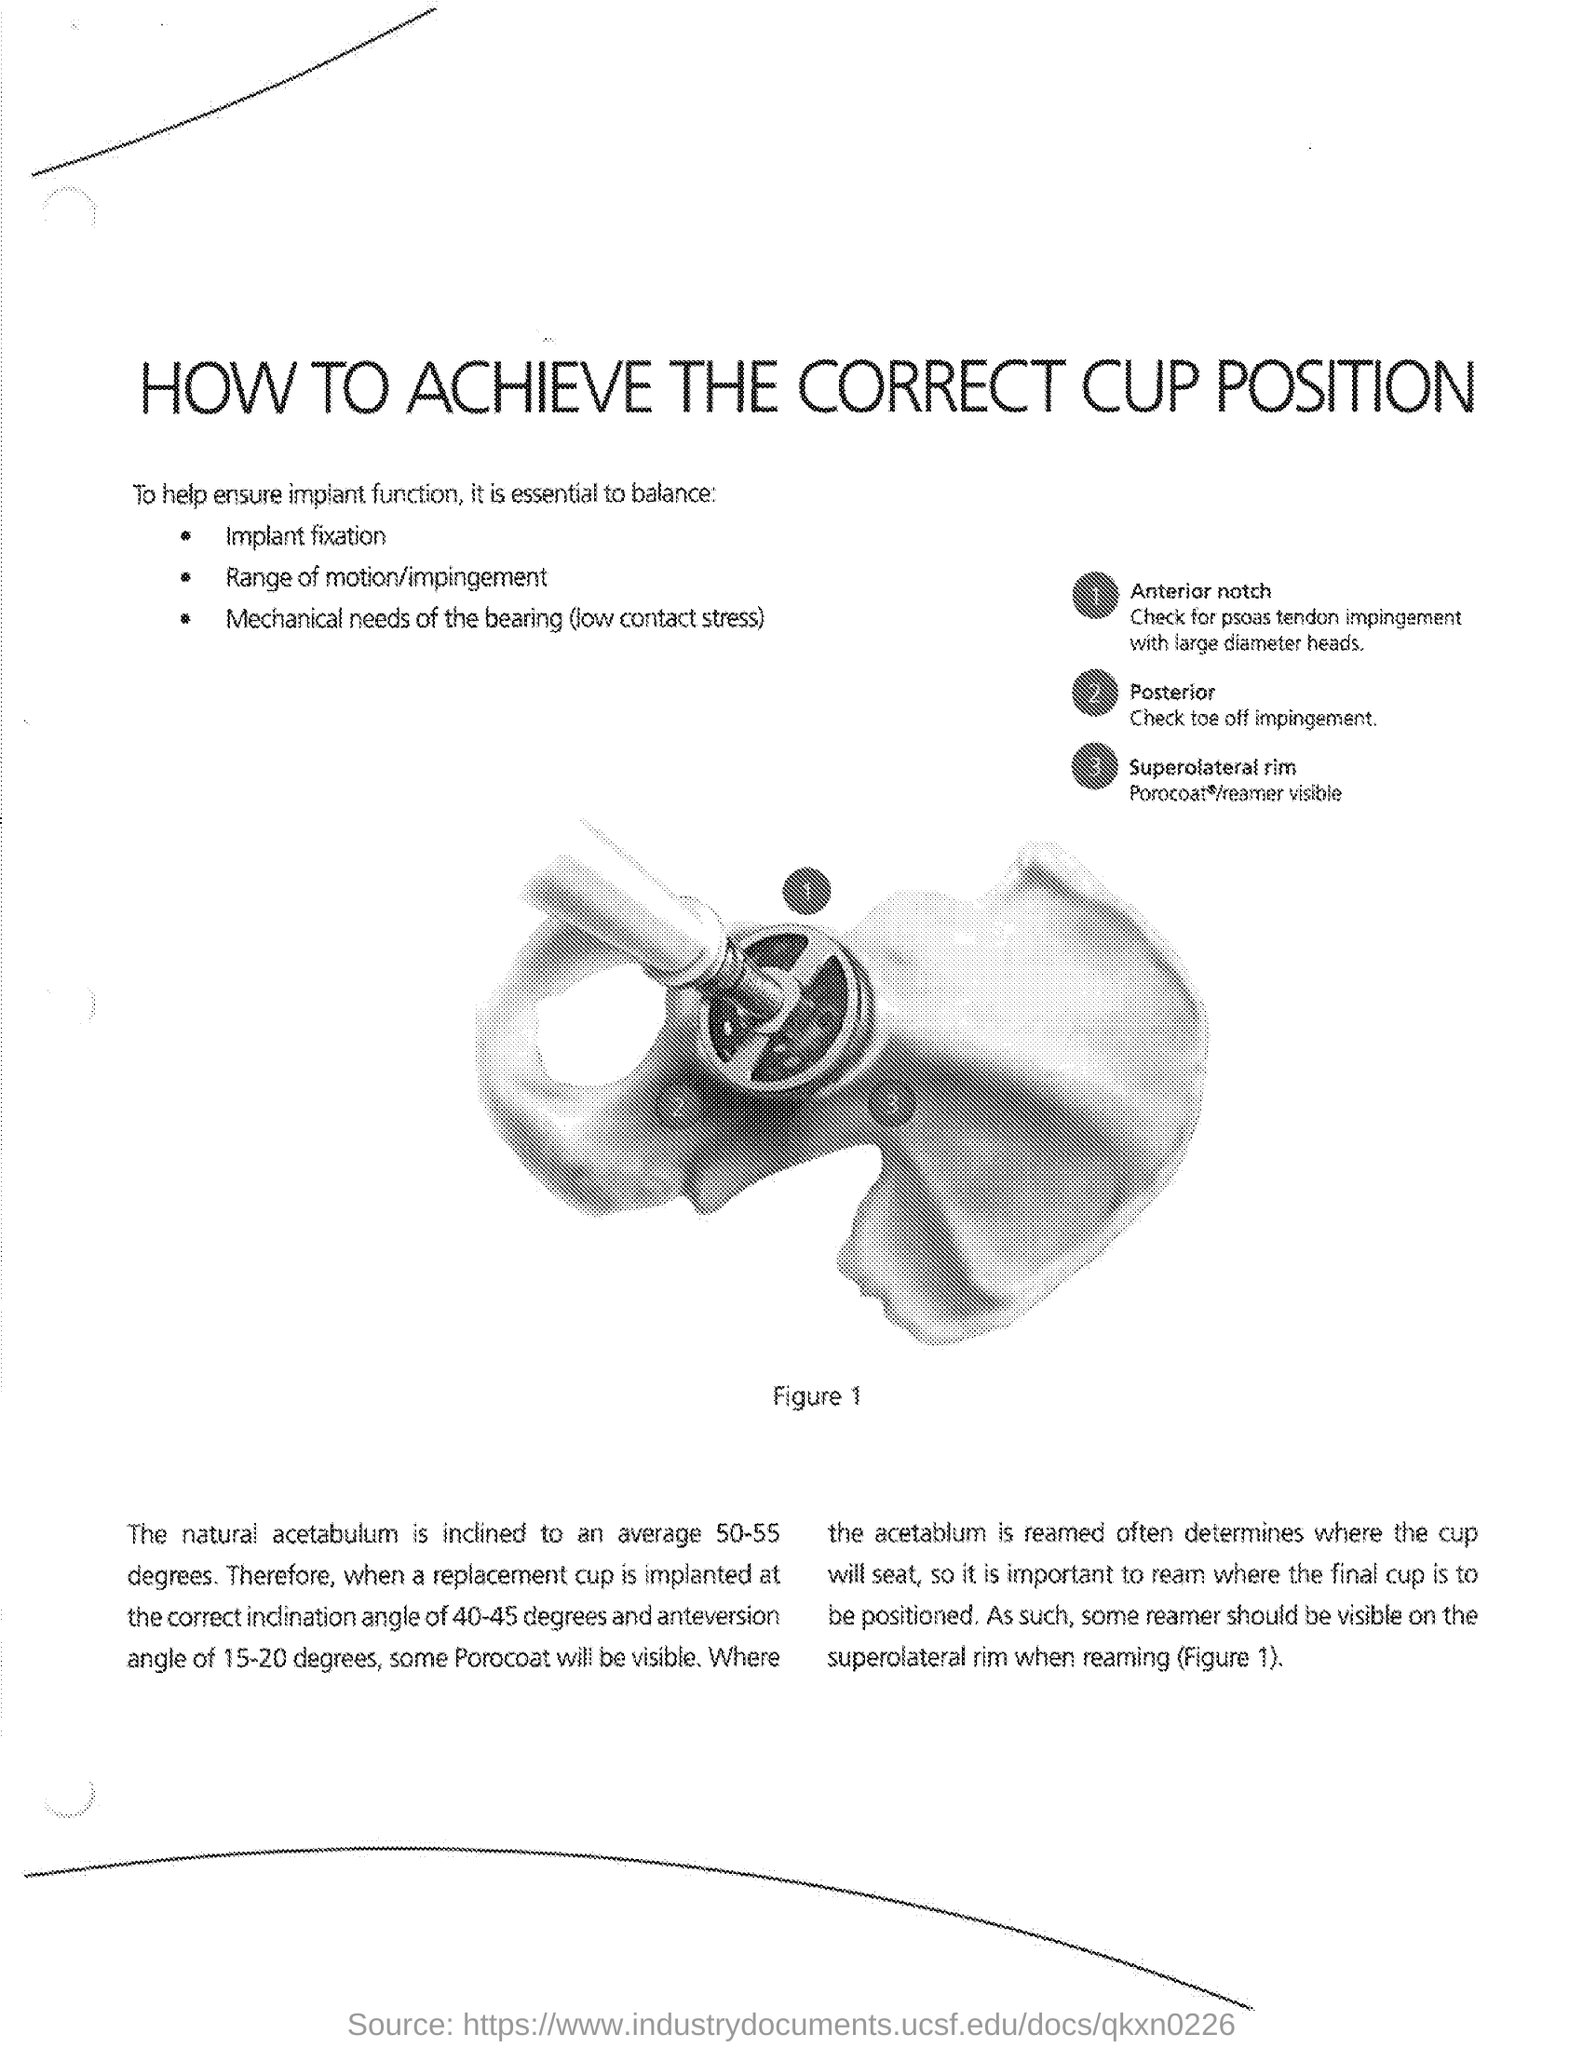Outline some significant characteristics in this image. This document is titled 'How to Achieve the Correct Cup Position' and it provides guidance on the proper placement of cups in a binder. 